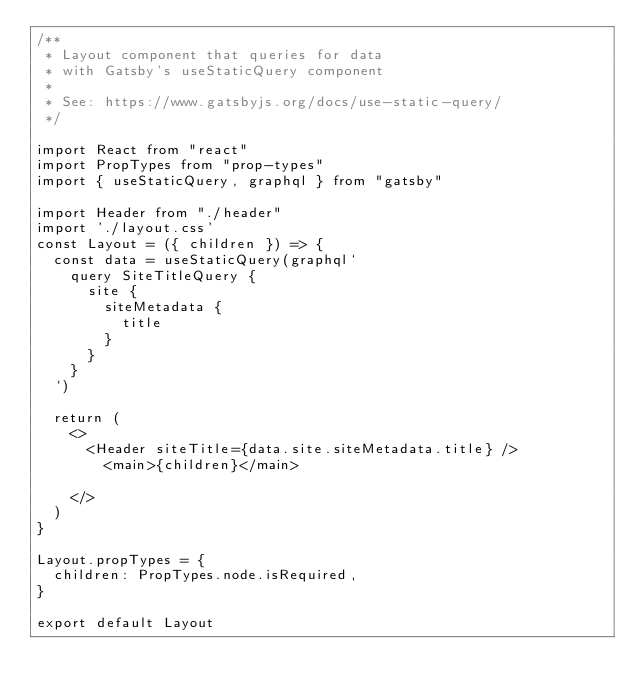Convert code to text. <code><loc_0><loc_0><loc_500><loc_500><_JavaScript_>/**
 * Layout component that queries for data
 * with Gatsby's useStaticQuery component
 *
 * See: https://www.gatsbyjs.org/docs/use-static-query/
 */

import React from "react"
import PropTypes from "prop-types"
import { useStaticQuery, graphql } from "gatsby"

import Header from "./header"
import './layout.css'
const Layout = ({ children }) => {
  const data = useStaticQuery(graphql`
    query SiteTitleQuery {
      site {
        siteMetadata {
          title
        }
      }
    }
  `)

  return (
    <>
      <Header siteTitle={data.site.siteMetadata.title} />
        <main>{children}</main>
        
    </>
  )
}

Layout.propTypes = {
  children: PropTypes.node.isRequired,
}

export default Layout
</code> 